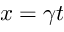Convert formula to latex. <formula><loc_0><loc_0><loc_500><loc_500>x = \gamma t</formula> 